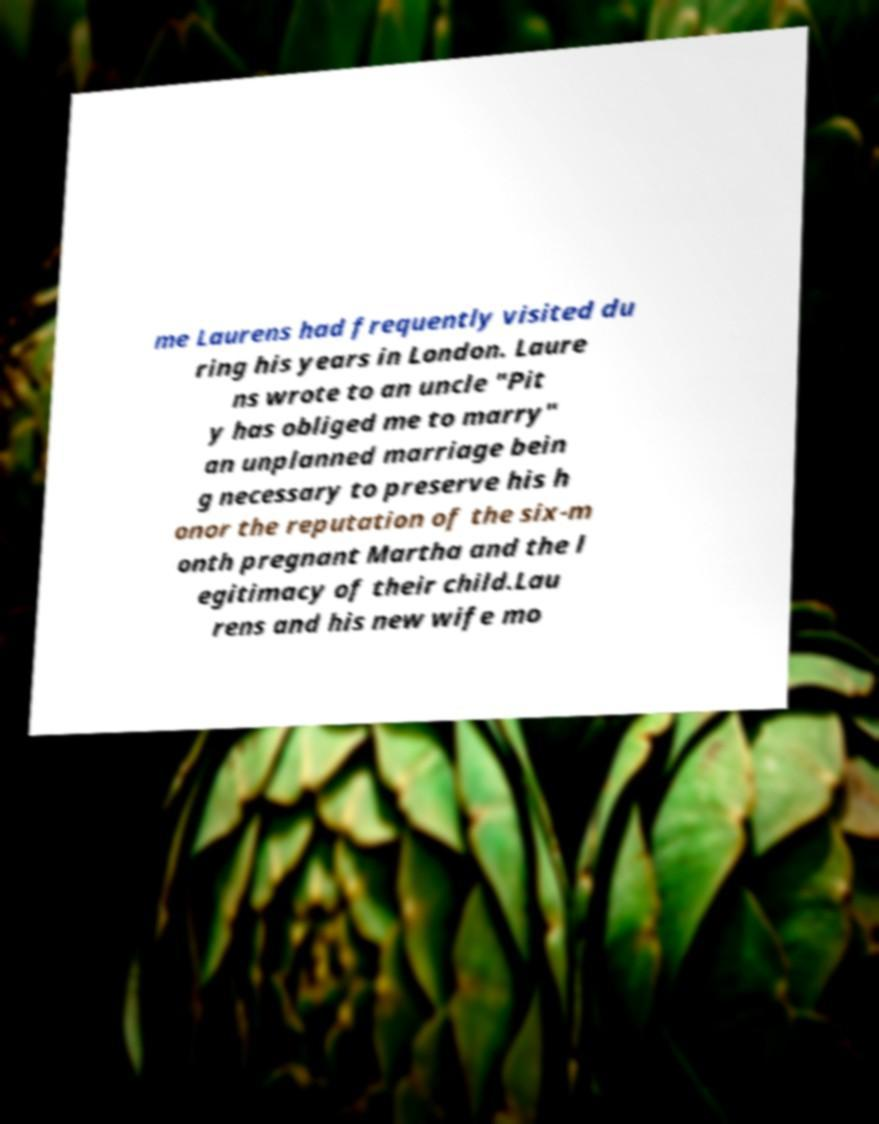For documentation purposes, I need the text within this image transcribed. Could you provide that? me Laurens had frequently visited du ring his years in London. Laure ns wrote to an uncle "Pit y has obliged me to marry" an unplanned marriage bein g necessary to preserve his h onor the reputation of the six-m onth pregnant Martha and the l egitimacy of their child.Lau rens and his new wife mo 